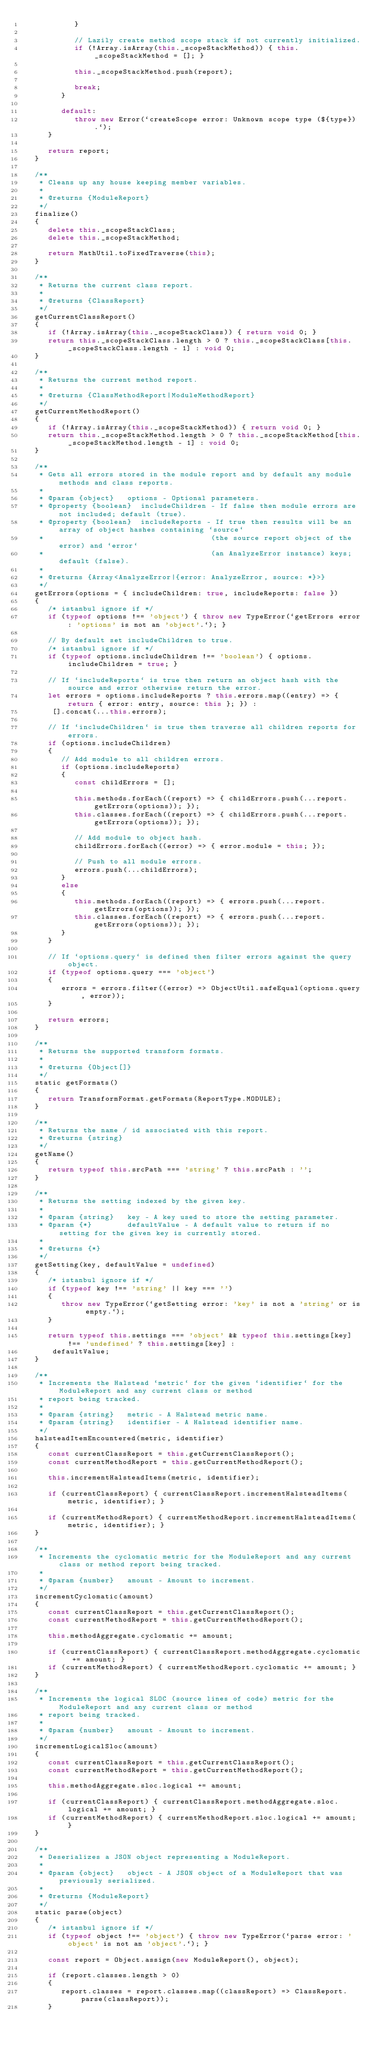<code> <loc_0><loc_0><loc_500><loc_500><_JavaScript_>            }

            // Lazily create method scope stack if not currently initialized.
            if (!Array.isArray(this._scopeStackMethod)) { this._scopeStackMethod = []; }

            this._scopeStackMethod.push(report);

            break;
         }

         default:
            throw new Error(`createScope error: Unknown scope type (${type}).`);
      }

      return report;
   }

   /**
    * Cleans up any house keeping member variables.
    *
    * @returns {ModuleReport}
    */
   finalize()
   {
      delete this._scopeStackClass;
      delete this._scopeStackMethod;

      return MathUtil.toFixedTraverse(this);
   }

   /**
    * Returns the current class report.
    *
    * @returns {ClassReport}
    */
   getCurrentClassReport()
   {
      if (!Array.isArray(this._scopeStackClass)) { return void 0; }
      return this._scopeStackClass.length > 0 ? this._scopeStackClass[this._scopeStackClass.length - 1] : void 0;
   }

   /**
    * Returns the current method report.
    *
    * @returns {ClassMethodReport|ModuleMethodReport}
    */
   getCurrentMethodReport()
   {
      if (!Array.isArray(this._scopeStackMethod)) { return void 0; }
      return this._scopeStackMethod.length > 0 ? this._scopeStackMethod[this._scopeStackMethod.length - 1] : void 0;
   }

   /**
    * Gets all errors stored in the module report and by default any module methods and class reports.
    *
    * @param {object}   options - Optional parameters.
    * @property {boolean}  includeChildren - If false then module errors are not included; default (true).
    * @property {boolean}  includeReports - If true then results will be an array of object hashes containing `source`
    *                                      (the source report object of the error) and `error`
    *                                      (an AnalyzeError instance) keys; default (false).
    *
    * @returns {Array<AnalyzeError|{error: AnalyzeError, source: *}>}
    */
   getErrors(options = { includeChildren: true, includeReports: false })
   {
      /* istanbul ignore if */
      if (typeof options !== 'object') { throw new TypeError(`getErrors error: 'options' is not an 'object'.`); }

      // By default set includeChildren to true.
      /* istanbul ignore if */
      if (typeof options.includeChildren !== 'boolean') { options.includeChildren = true; }

      // If `includeReports` is true then return an object hash with the source and error otherwise return the error.
      let errors = options.includeReports ? this.errors.map((entry) => { return { error: entry, source: this }; }) :
       [].concat(...this.errors);

      // If `includeChildren` is true then traverse all children reports for errors.
      if (options.includeChildren)
      {
         // Add module to all children errors.
         if (options.includeReports)
         {
            const childErrors = [];

            this.methods.forEach((report) => { childErrors.push(...report.getErrors(options)); });
            this.classes.forEach((report) => { childErrors.push(...report.getErrors(options)); });

            // Add module to object hash.
            childErrors.forEach((error) => { error.module = this; });

            // Push to all module errors.
            errors.push(...childErrors);
         }
         else
         {
            this.methods.forEach((report) => { errors.push(...report.getErrors(options)); });
            this.classes.forEach((report) => { errors.push(...report.getErrors(options)); });
         }
      }

      // If `options.query` is defined then filter errors against the query object.
      if (typeof options.query === 'object')
      {
         errors = errors.filter((error) => ObjectUtil.safeEqual(options.query, error));
      }

      return errors;
   }

   /**
    * Returns the supported transform formats.
    *
    * @returns {Object[]}
    */
   static getFormats()
   {
      return TransformFormat.getFormats(ReportType.MODULE);
   }

   /**
    * Returns the name / id associated with this report.
    * @returns {string}
    */
   getName()
   {
      return typeof this.srcPath === 'string' ? this.srcPath : '';
   }

   /**
    * Returns the setting indexed by the given key.
    *
    * @param {string}   key - A key used to store the setting parameter.
    * @param {*}        defaultValue - A default value to return if no setting for the given key is currently stored.
    *
    * @returns {*}
    */
   getSetting(key, defaultValue = undefined)
   {
      /* istanbul ignore if */
      if (typeof key !== 'string' || key === '')
      {
         throw new TypeError(`getSetting error: 'key' is not a 'string' or is empty.`);
      }

      return typeof this.settings === 'object' && typeof this.settings[key] !== 'undefined' ? this.settings[key] :
       defaultValue;
   }

   /**
    * Increments the Halstead `metric` for the given `identifier` for the ModuleReport and any current class or method
    * report being tracked.
    *
    * @param {string}   metric - A Halstead metric name.
    * @param {string}   identifier - A Halstead identifier name.
    */
   halsteadItemEncountered(metric, identifier)
   {
      const currentClassReport = this.getCurrentClassReport();
      const currentMethodReport = this.getCurrentMethodReport();

      this.incrementHalsteadItems(metric, identifier);

      if (currentClassReport) { currentClassReport.incrementHalsteadItems(metric, identifier); }

      if (currentMethodReport) { currentMethodReport.incrementHalsteadItems(metric, identifier); }
   }

   /**
    * Increments the cyclomatic metric for the ModuleReport and any current class or method report being tracked.
    *
    * @param {number}   amount - Amount to increment.
    */
   incrementCyclomatic(amount)
   {
      const currentClassReport = this.getCurrentClassReport();
      const currentMethodReport = this.getCurrentMethodReport();

      this.methodAggregate.cyclomatic += amount;

      if (currentClassReport) { currentClassReport.methodAggregate.cyclomatic += amount; }
      if (currentMethodReport) { currentMethodReport.cyclomatic += amount; }
   }

   /**
    * Increments the logical SLOC (source lines of code) metric for the ModuleReport and any current class or method
    * report being tracked.
    *
    * @param {number}   amount - Amount to increment.
    */
   incrementLogicalSloc(amount)
   {
      const currentClassReport = this.getCurrentClassReport();
      const currentMethodReport = this.getCurrentMethodReport();

      this.methodAggregate.sloc.logical += amount;

      if (currentClassReport) { currentClassReport.methodAggregate.sloc.logical += amount; }
      if (currentMethodReport) { currentMethodReport.sloc.logical += amount; }
   }

   /**
    * Deserializes a JSON object representing a ModuleReport.
    *
    * @param {object}   object - A JSON object of a ModuleReport that was previously serialized.
    *
    * @returns {ModuleReport}
    */
   static parse(object)
   {
      /* istanbul ignore if */
      if (typeof object !== 'object') { throw new TypeError(`parse error: 'object' is not an 'object'.`); }

      const report = Object.assign(new ModuleReport(), object);

      if (report.classes.length > 0)
      {
         report.classes = report.classes.map((classReport) => ClassReport.parse(classReport));
      }
</code> 